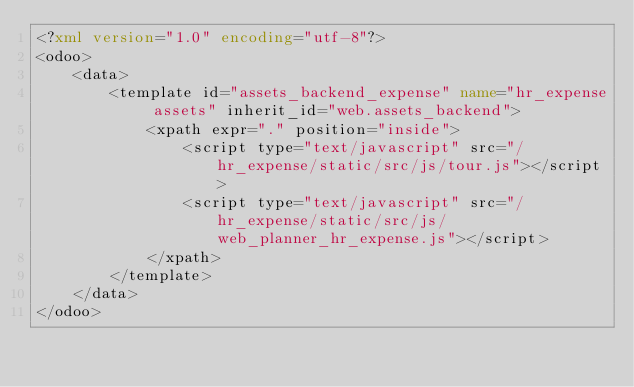<code> <loc_0><loc_0><loc_500><loc_500><_XML_><?xml version="1.0" encoding="utf-8"?>
<odoo>
    <data>
        <template id="assets_backend_expense" name="hr_expense assets" inherit_id="web.assets_backend">
            <xpath expr="." position="inside">
                <script type="text/javascript" src="/hr_expense/static/src/js/tour.js"></script>
                <script type="text/javascript" src="/hr_expense/static/src/js/web_planner_hr_expense.js"></script>
            </xpath>
        </template>
    </data>
</odoo>
</code> 